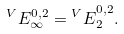<formula> <loc_0><loc_0><loc_500><loc_500>^ { V } E _ { \infty } ^ { 0 , 2 } = { ^ { V } E } _ { 2 } ^ { 0 , 2 } .</formula> 